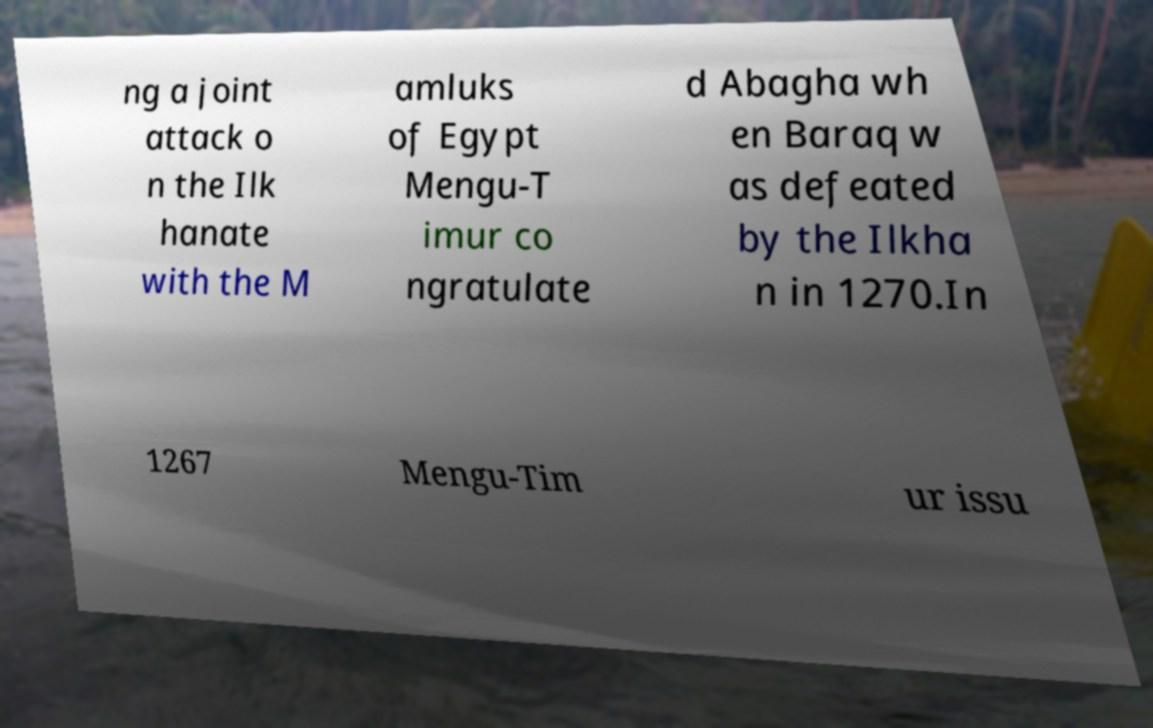Can you read and provide the text displayed in the image?This photo seems to have some interesting text. Can you extract and type it out for me? ng a joint attack o n the Ilk hanate with the M amluks of Egypt Mengu-T imur co ngratulate d Abagha wh en Baraq w as defeated by the Ilkha n in 1270.In 1267 Mengu-Tim ur issu 